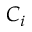<formula> <loc_0><loc_0><loc_500><loc_500>C _ { i }</formula> 